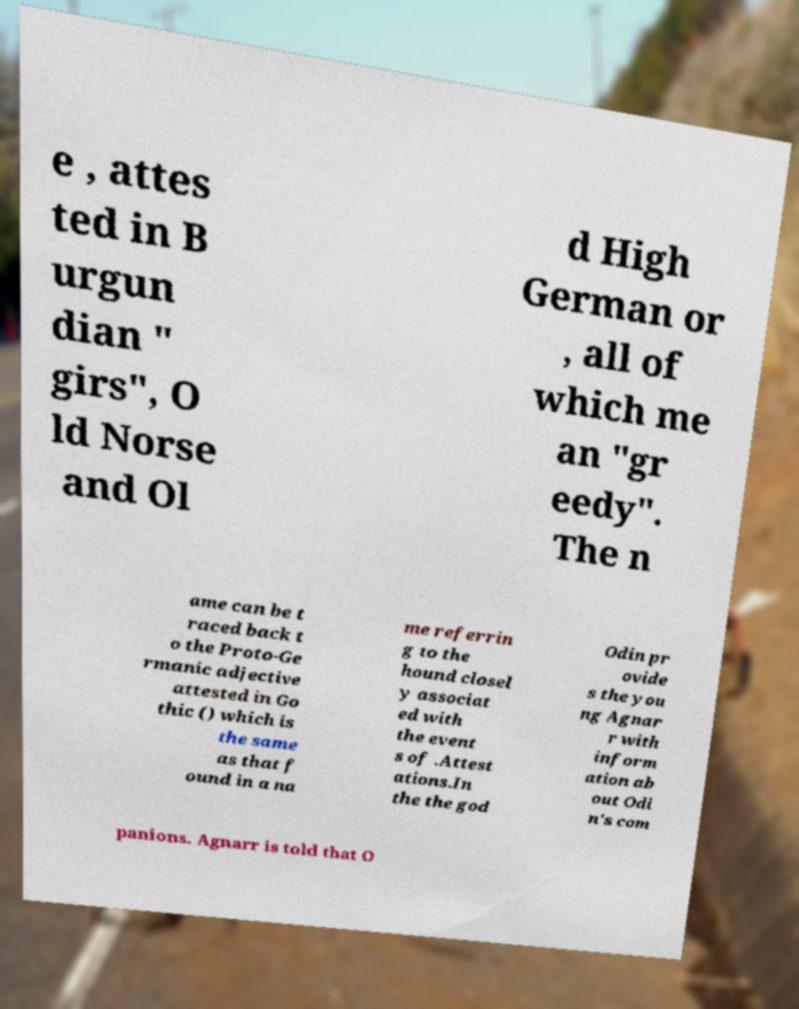What messages or text are displayed in this image? I need them in a readable, typed format. e , attes ted in B urgun dian " girs", O ld Norse and Ol d High German or , all of which me an "gr eedy". The n ame can be t raced back t o the Proto-Ge rmanic adjective attested in Go thic () which is the same as that f ound in a na me referrin g to the hound closel y associat ed with the event s of .Attest ations.In the the god Odin pr ovide s the you ng Agnar r with inform ation ab out Odi n's com panions. Agnarr is told that O 